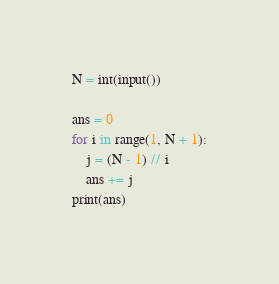Convert code to text. <code><loc_0><loc_0><loc_500><loc_500><_Python_>N = int(input())

ans = 0
for i in range(1, N + 1):
    j = (N - 1) // i
    ans += j
print(ans)
</code> 